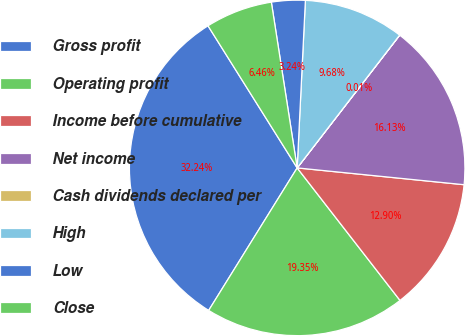Convert chart. <chart><loc_0><loc_0><loc_500><loc_500><pie_chart><fcel>Gross profit<fcel>Operating profit<fcel>Income before cumulative<fcel>Net income<fcel>Cash dividends declared per<fcel>High<fcel>Low<fcel>Close<nl><fcel>32.24%<fcel>19.35%<fcel>12.9%<fcel>16.13%<fcel>0.01%<fcel>9.68%<fcel>3.24%<fcel>6.46%<nl></chart> 